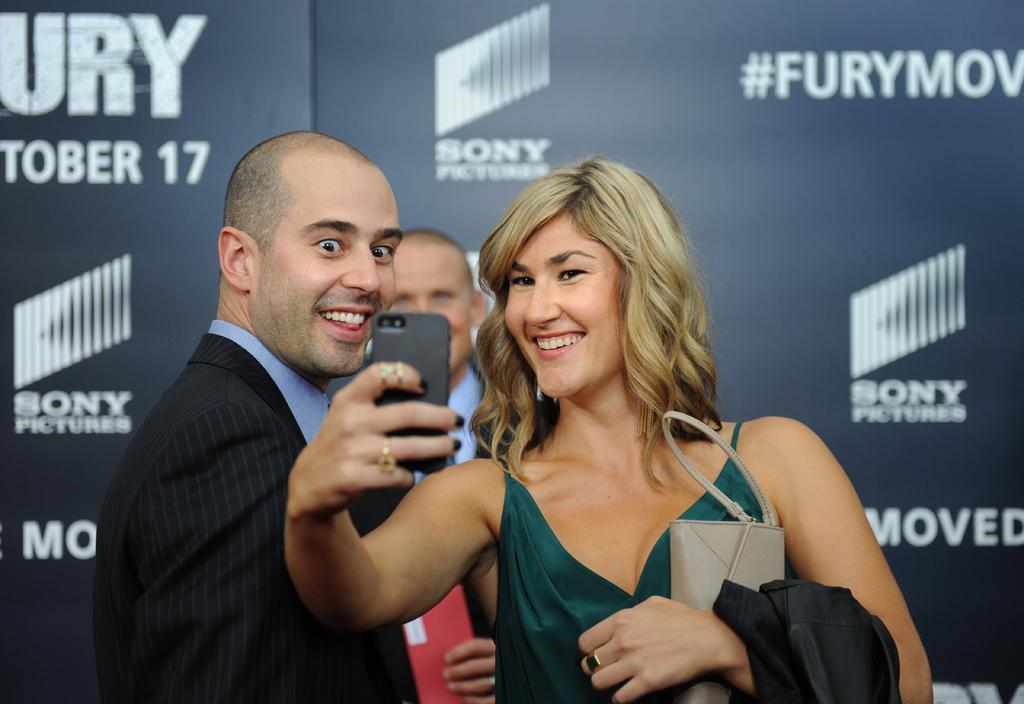Who is the main subject in the image? There is a lady in the center of the image. What is the lady doing in the image? The lady is standing in the image. What objects is the lady holding in her hands? The lady is holding a mobile and a wallet in her hands. Are there any other people in the image? Yes, there are two people next to the lady. What can be seen in the background of the image? There is a board visible in the background of the image. What year is depicted on the cart next to the lady in the image? There is no cart present in the image, and therefore no year can be observed. 